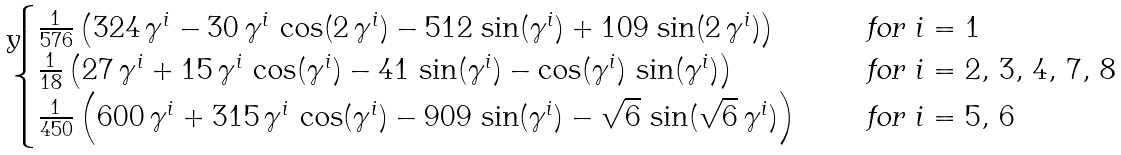Convert formula to latex. <formula><loc_0><loc_0><loc_500><loc_500>\begin{cases} \frac { 1 } { 5 7 6 } \left ( { 3 2 4 \, \gamma ^ { i } - 3 0 \, \gamma ^ { i } \, \cos ( 2 \, \gamma ^ { i } ) - 5 1 2 \, \sin ( \gamma ^ { i } ) + 1 0 9 \, \sin ( 2 \, \gamma ^ { i } ) } \right ) & \quad \text { for $i=1 $} \\ \frac { 1 } { 1 8 } \left ( { 2 7 \, \gamma ^ { i } + 1 5 \, \gamma ^ { i } \, \cos ( \gamma ^ { i } ) - 4 1 \, \sin ( \gamma ^ { i } ) - \cos ( \gamma ^ { i } ) \, \sin ( \gamma ^ { i } ) } \right ) & \quad \text { for $i=2,\, 3 , \, 4, \, 7, \, 8 $} \\ \frac { 1 } { 4 5 0 } \left ( { 6 0 0 \, \gamma ^ { i } + 3 1 5 \, \gamma ^ { i } \, \cos ( \gamma ^ { i } ) - 9 0 9 \, \sin ( \gamma ^ { i } ) - { \sqrt { 6 } } \, \sin ( { \sqrt { 6 } } \, \gamma ^ { i } ) } \right ) & \quad \text { for $i=5, \, 6 $} \end{cases}</formula> 